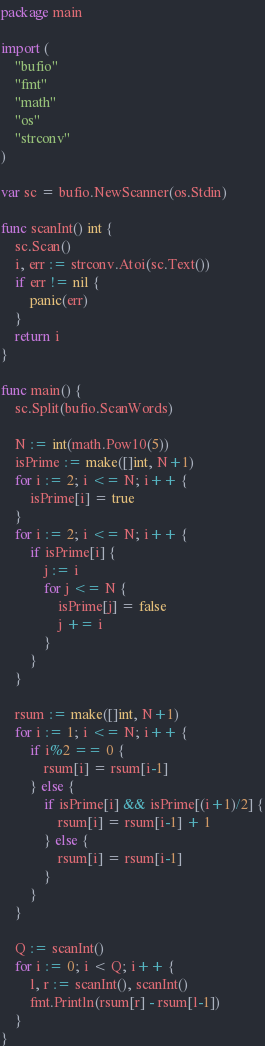<code> <loc_0><loc_0><loc_500><loc_500><_Go_>package main

import (
	"bufio"
	"fmt"
	"math"
	"os"
	"strconv"
)

var sc = bufio.NewScanner(os.Stdin)

func scanInt() int {
	sc.Scan()
	i, err := strconv.Atoi(sc.Text())
	if err != nil {
		panic(err)
	}
	return i
}

func main() {
	sc.Split(bufio.ScanWords)

	N := int(math.Pow10(5))
	isPrime := make([]int, N+1)
	for i := 2; i <= N; i++ {
		isPrime[i] = true
	}
	for i := 2; i <= N; i++ {
		if isPrime[i] {
			j := i
			for j <= N {
				isPrime[j] = false
				j += i
			}
		}
	}

	rsum := make([]int, N+1)
	for i := 1; i <= N; i++ {
		if i%2 == 0 {
			rsum[i] = rsum[i-1]
		} else {
			if isPrime[i] && isPrime[(i+1)/2] {
				rsum[i] = rsum[i-1] + 1
			} else {
				rsum[i] = rsum[i-1]
			}
		}
	}

	Q := scanInt()
	for i := 0; i < Q; i++ {
		l, r := scanInt(), scanInt()
		fmt.Println(rsum[r] - rsum[l-1])
	}
}
</code> 